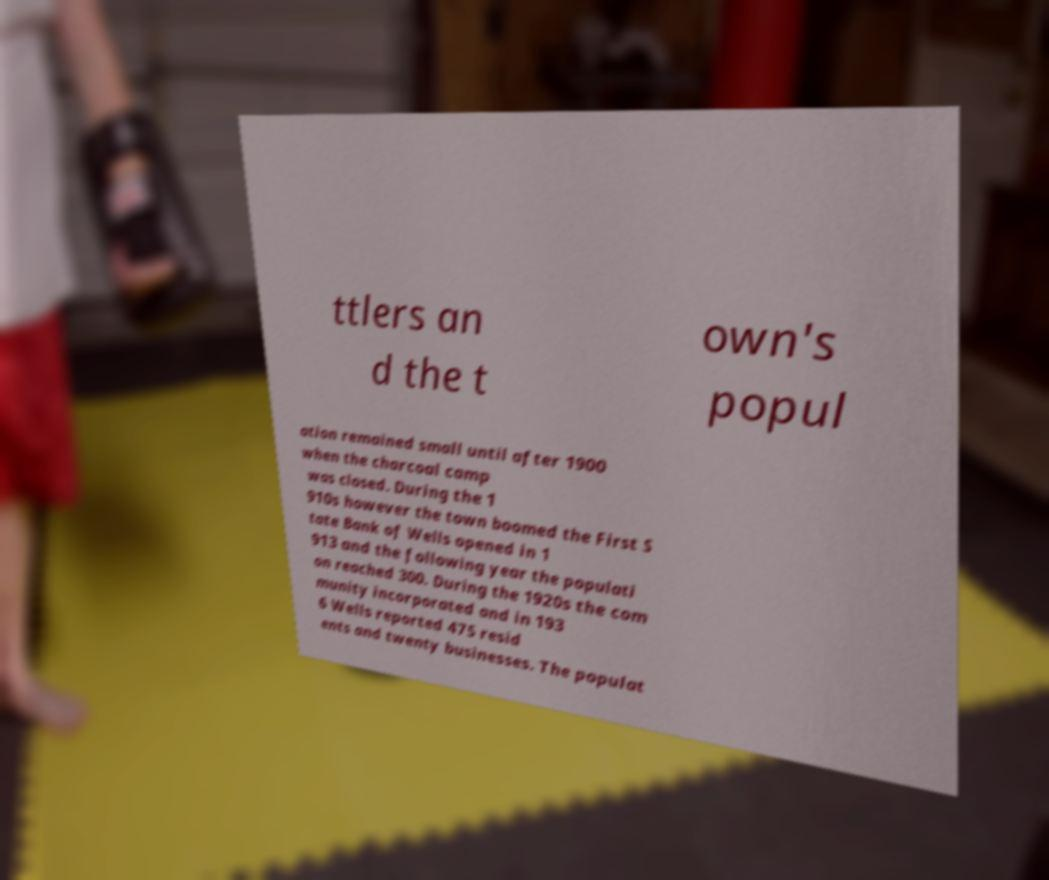Please identify and transcribe the text found in this image. ttlers an d the t own's popul ation remained small until after 1900 when the charcoal camp was closed. During the 1 910s however the town boomed the First S tate Bank of Wells opened in 1 913 and the following year the populati on reached 300. During the 1920s the com munity incorporated and in 193 6 Wells reported 475 resid ents and twenty businesses. The populat 